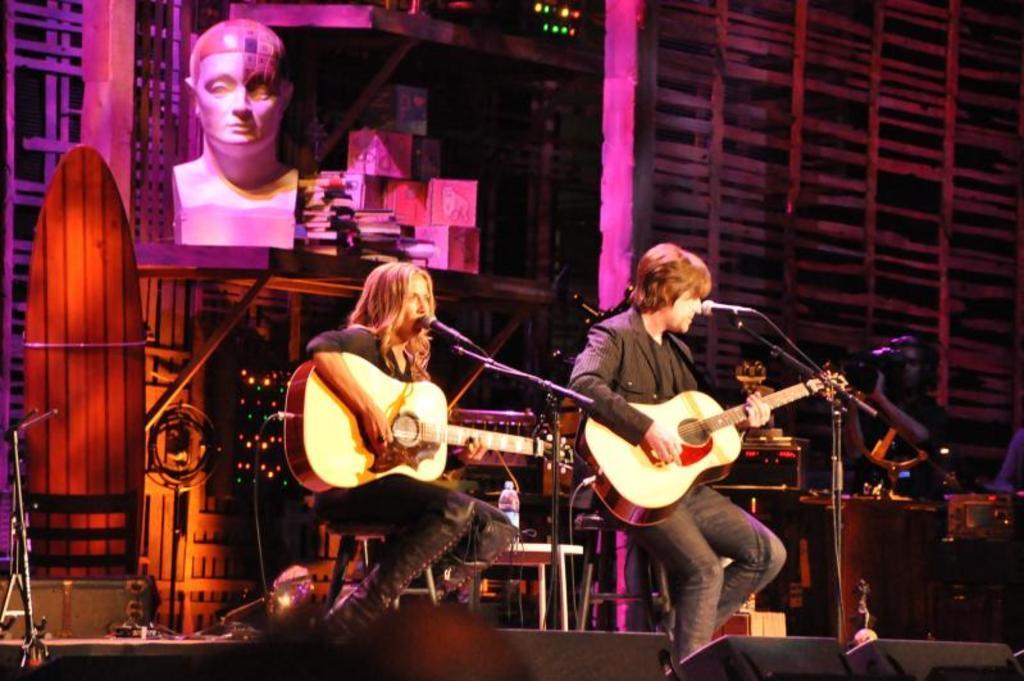How would you summarize this image in a sentence or two? In this image we can see two people are sitting and playing guitar. They are singing through the mic in front of them. In the background we can see a person holding video camera. 